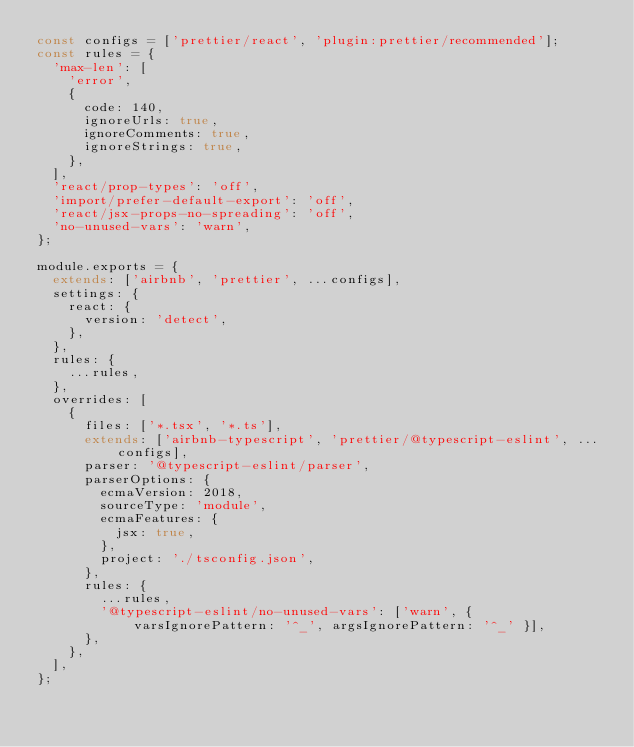Convert code to text. <code><loc_0><loc_0><loc_500><loc_500><_JavaScript_>const configs = ['prettier/react', 'plugin:prettier/recommended'];
const rules = {
  'max-len': [
    'error',
    {
      code: 140,
      ignoreUrls: true,
      ignoreComments: true,
      ignoreStrings: true,
    },
  ],
  'react/prop-types': 'off',
  'import/prefer-default-export': 'off',
  'react/jsx-props-no-spreading': 'off',
  'no-unused-vars': 'warn',
};

module.exports = {
  extends: ['airbnb', 'prettier', ...configs],
  settings: {
    react: {
      version: 'detect',
    },
  },
  rules: {
    ...rules,
  },
  overrides: [
    {
      files: ['*.tsx', '*.ts'],
      extends: ['airbnb-typescript', 'prettier/@typescript-eslint', ...configs],
      parser: '@typescript-eslint/parser',
      parserOptions: {
        ecmaVersion: 2018,
        sourceType: 'module',
        ecmaFeatures: {
          jsx: true,
        },
        project: './tsconfig.json',
      },
      rules: {
        ...rules,
        '@typescript-eslint/no-unused-vars': ['warn', { varsIgnorePattern: '^_', argsIgnorePattern: '^_' }],
      },
    },
  ],
};
</code> 